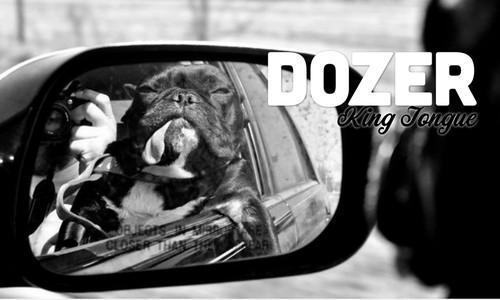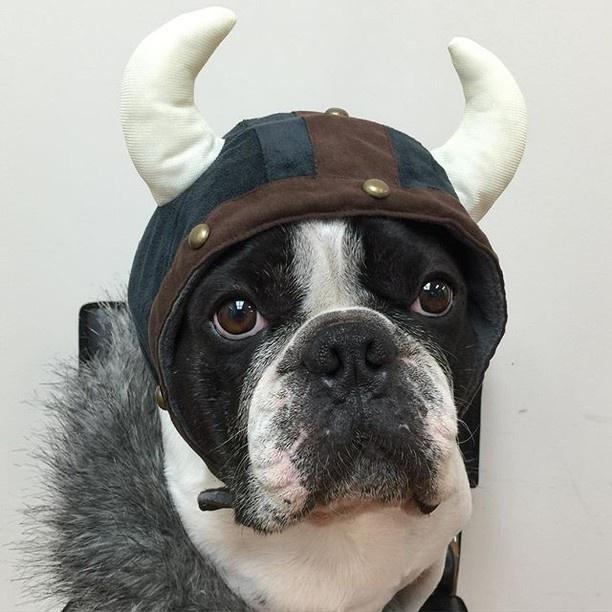The first image is the image on the left, the second image is the image on the right. Evaluate the accuracy of this statement regarding the images: "In one of the images the dog is wearing a hat.". Is it true? Answer yes or no. Yes. 